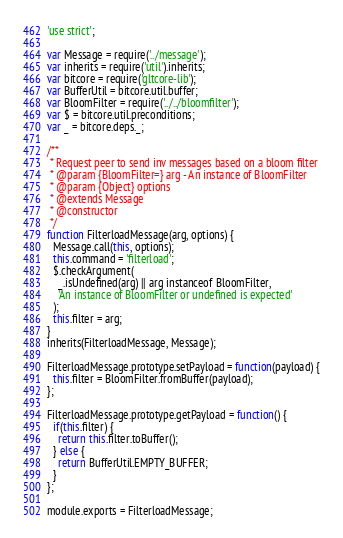<code> <loc_0><loc_0><loc_500><loc_500><_JavaScript_>'use strict';

var Message = require('../message');
var inherits = require('util').inherits;
var bitcore = require('gltcore-lib');
var BufferUtil = bitcore.util.buffer;
var BloomFilter = require('../../bloomfilter');
var $ = bitcore.util.preconditions;
var _ = bitcore.deps._;

/**
 * Request peer to send inv messages based on a bloom filter
 * @param {BloomFilter=} arg - An instance of BloomFilter
 * @param {Object} options
 * @extends Message
 * @constructor
 */
function FilterloadMessage(arg, options) {
  Message.call(this, options);
  this.command = 'filterload';
  $.checkArgument(
    _.isUndefined(arg) || arg instanceof BloomFilter,
    'An instance of BloomFilter or undefined is expected'
  );
  this.filter = arg;
}
inherits(FilterloadMessage, Message);

FilterloadMessage.prototype.setPayload = function(payload) {
  this.filter = BloomFilter.fromBuffer(payload);
};

FilterloadMessage.prototype.getPayload = function() {
  if(this.filter) {
    return this.filter.toBuffer();
  } else {
    return BufferUtil.EMPTY_BUFFER;
  }
};

module.exports = FilterloadMessage;
</code> 